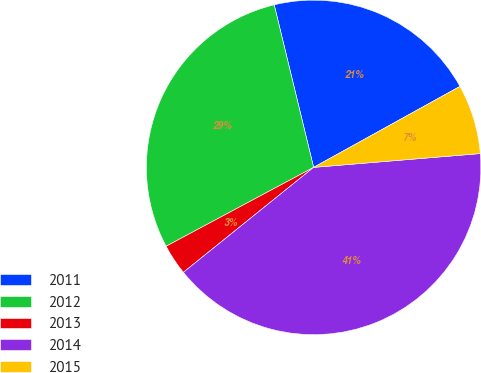<chart> <loc_0><loc_0><loc_500><loc_500><pie_chart><fcel>2011<fcel>2012<fcel>2013<fcel>2014<fcel>2015<nl><fcel>20.74%<fcel>29.03%<fcel>2.98%<fcel>40.52%<fcel>6.73%<nl></chart> 